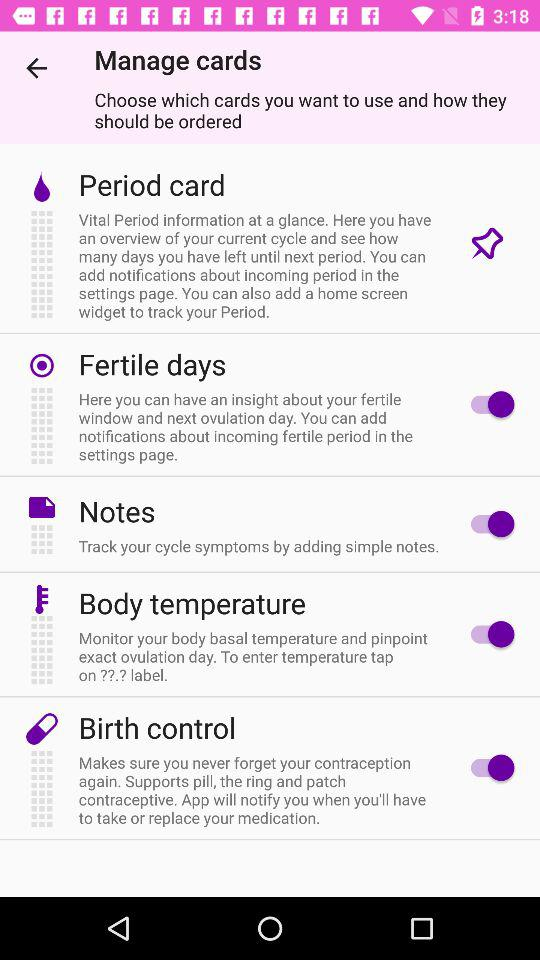How many cards are there on this screen?
Answer the question using a single word or phrase. 5 